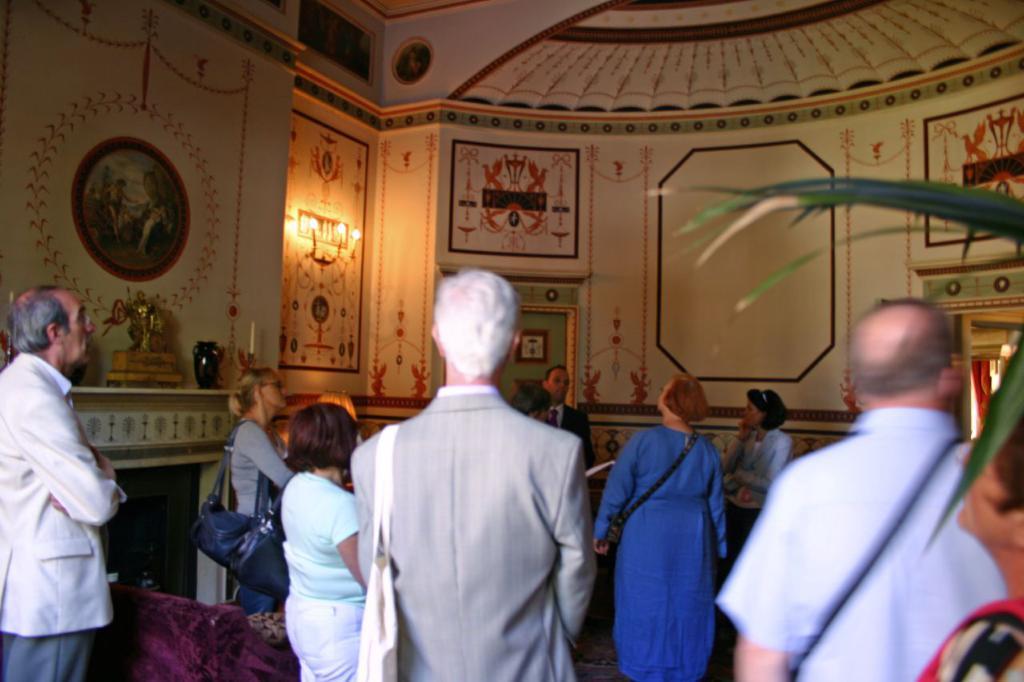Could you give a brief overview of what you see in this image? In this image I can see a group of people and a sofa on the floor. In the background I can see a wall, wall paintings, sculptures, vase and a houseplant. This image is taken may be in a church. 